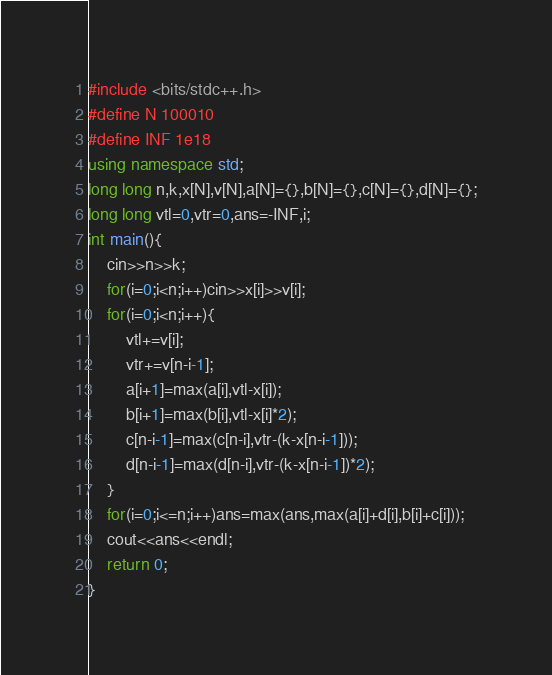<code> <loc_0><loc_0><loc_500><loc_500><_C++_>#include <bits/stdc++.h>
#define N 100010
#define INF 1e18
using namespace std;
long long n,k,x[N],v[N],a[N]={},b[N]={},c[N]={},d[N]={};
long long vtl=0,vtr=0,ans=-INF,i;
int main(){
	cin>>n>>k;
	for(i=0;i<n;i++)cin>>x[i]>>v[i];
	for(i=0;i<n;i++){
		vtl+=v[i];
		vtr+=v[n-i-1];
		a[i+1]=max(a[i],vtl-x[i]);
		b[i+1]=max(b[i],vtl-x[i]*2);
		c[n-i-1]=max(c[n-i],vtr-(k-x[n-i-1]));
		d[n-i-1]=max(d[n-i],vtr-(k-x[n-i-1])*2);
	}
	for(i=0;i<=n;i++)ans=max(ans,max(a[i]+d[i],b[i]+c[i]));
	cout<<ans<<endl;
	return 0;
}
</code> 